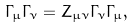Convert formula to latex. <formula><loc_0><loc_0><loc_500><loc_500>\Gamma _ { \mu } \Gamma _ { \nu } = Z _ { \mu \nu } \Gamma _ { \nu } \Gamma _ { \mu } ,</formula> 